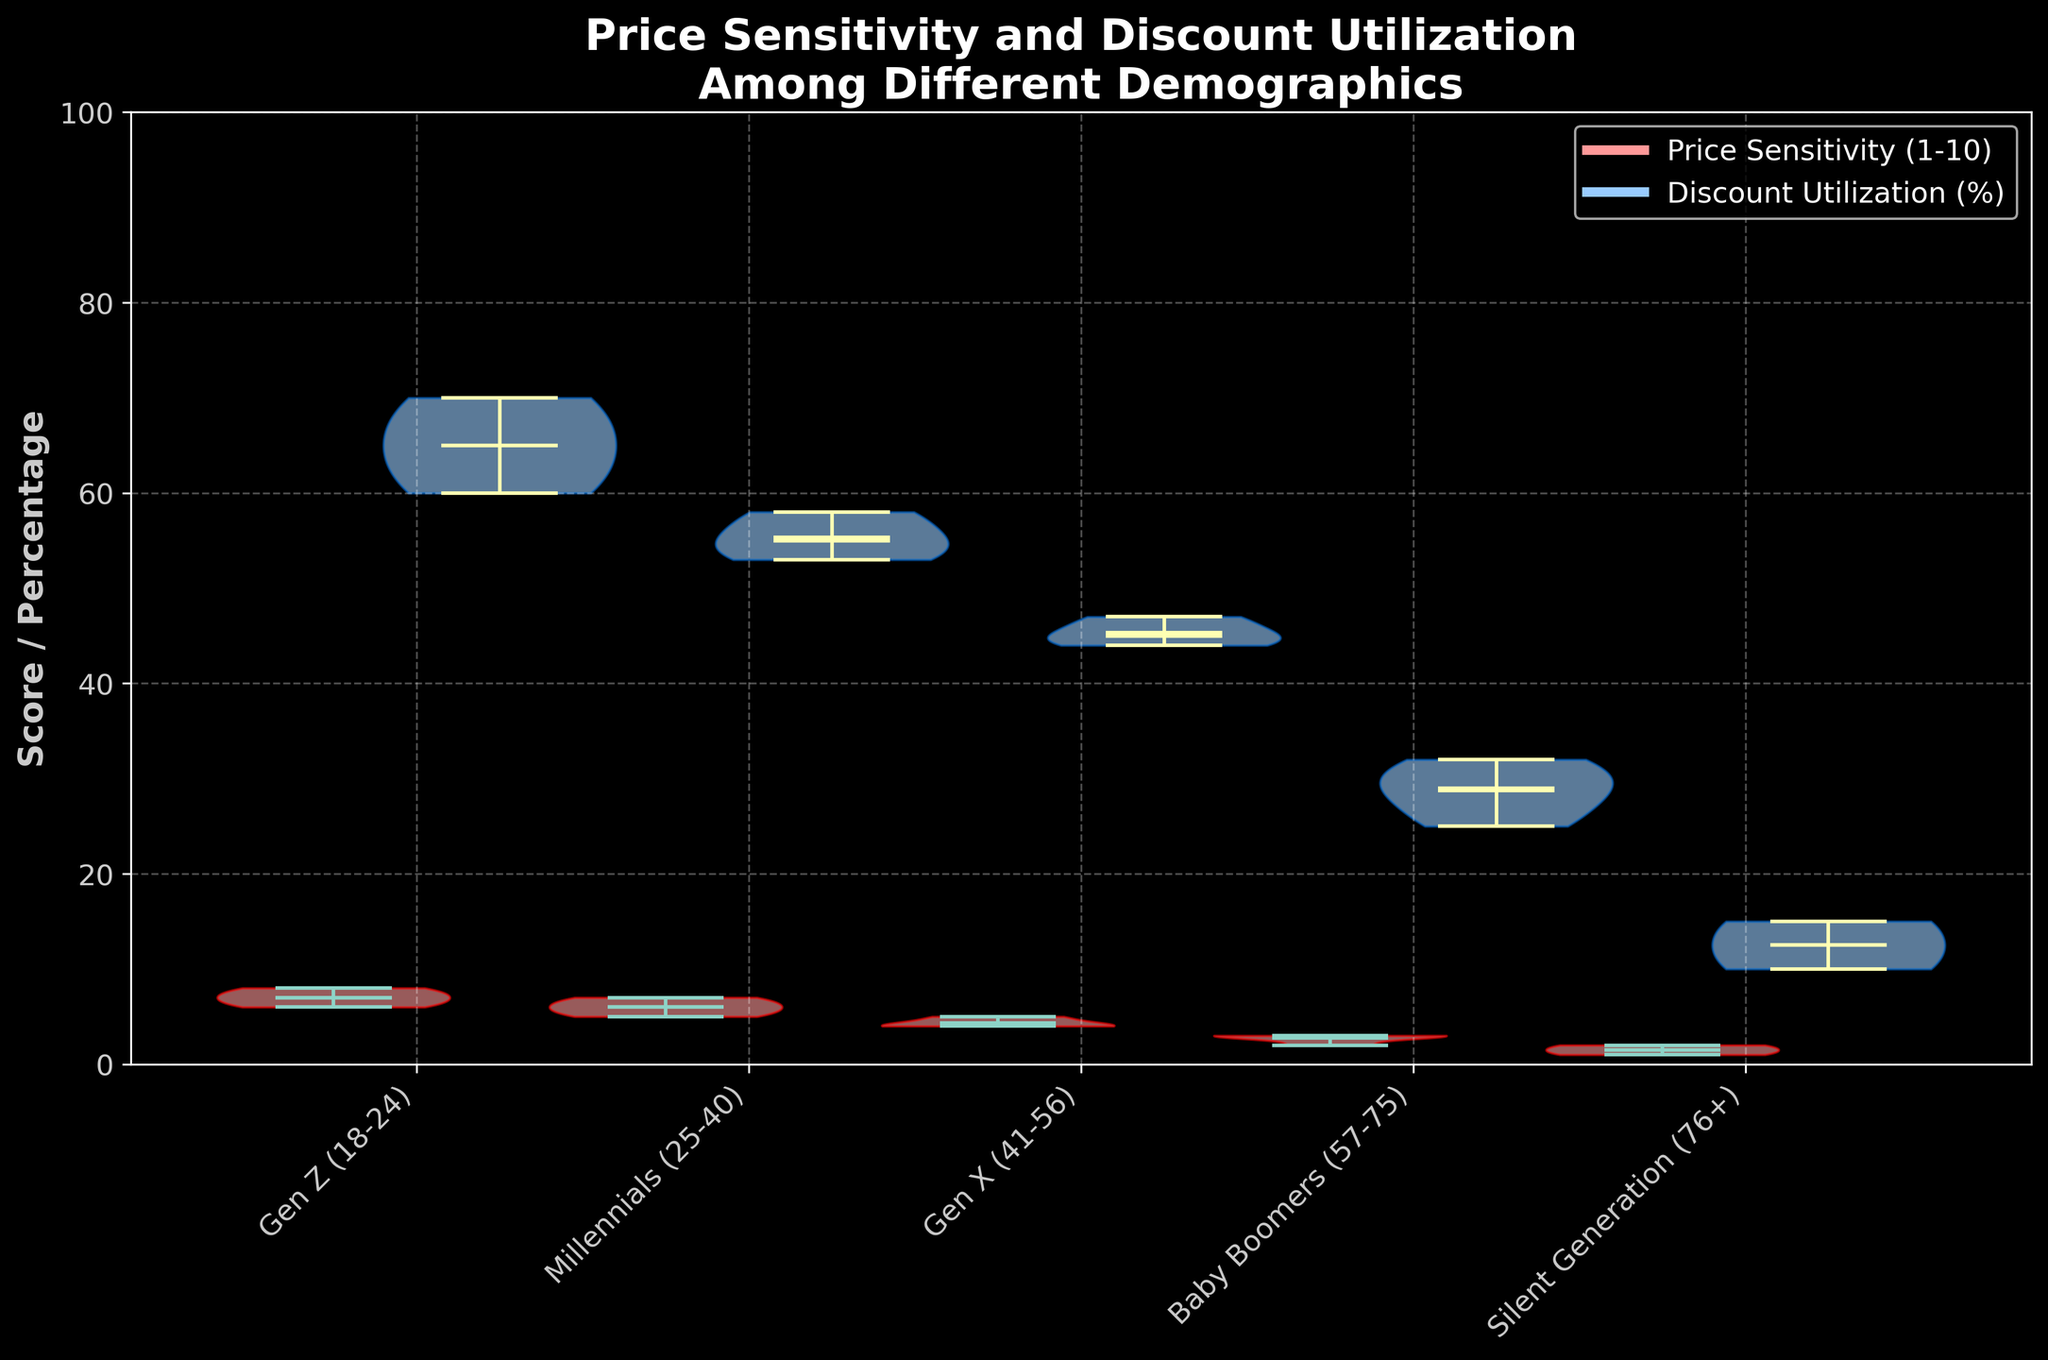What is the title of the figure? The title is shown at the top of the figure. It reads "Price Sensitivity and Discount Utilization Among Different Demographics".
Answer: Price Sensitivity and Discount Utilization Among Different Demographics Which demographic group has the highest mean price sensitivity? By observing the mean line in the violin plots, it can be seen that Gen Z (18-24) has the highest mean price sensitivity.
Answer: Gen Z (18-24) Which demographic group shows the lowest mean for discount utilization? The mean lines within the violin plots show that the Silent Generation (76+) has the lowest mean discount utilization.
Answer: Silent Generation (76+) How does the median price sensitivity of Millennials compare to that of Gen Z? The median line in the violin plot for Millennials (25-40) is lower than that for Gen Z (18-24). Thus, the median price sensitivity is lower for Millennials.
Answer: Lower What is the range of price sensitivity values for Gen X? Visually examining the extent of the violin plot for Gen X (41-56), it ranges from 4 to 5.
Answer: 4-5 Compare the spread of discount utilization between Baby Boomers and the Silent Generation. The violin plot for Baby Boomers (57-75) shows a wider spread (approximately from 25% to 32%) compared to the Silent Generation (76+) which is approximately from 10% to 15%.
Answer: Baby Boomers have a wider spread Which demographic has the most varied price sensitivity? By observing the width of the violin plots for price sensitivity, Gen Z (18-24) demonstrates the most variation.
Answer: Gen Z (18-24) Are there any groups where the mean price sensitivity is equal to the median price sensitivity? Examining the mean and median lines within the violin plots, Gen X (41-56) shows that the mean and median lines align.
Answer: Gen X (41-56) 